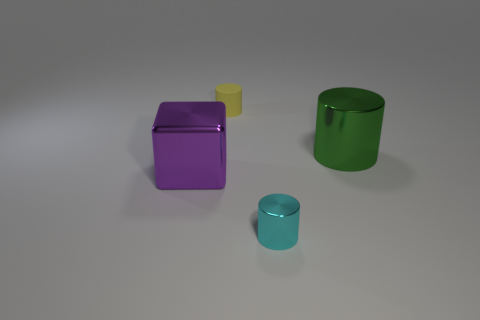How would you describe the lighting and shadows in the scene? The lighting in the image suggests a single light source coming from the upper left, resulting in shadows that fall predominantly to the right and slightly forward of each object. The shadows are soft-edged, indicating that the light source might be diffused. This setup gives the objects a subtle three-dimensional feel and accentuates their colors and textures. 